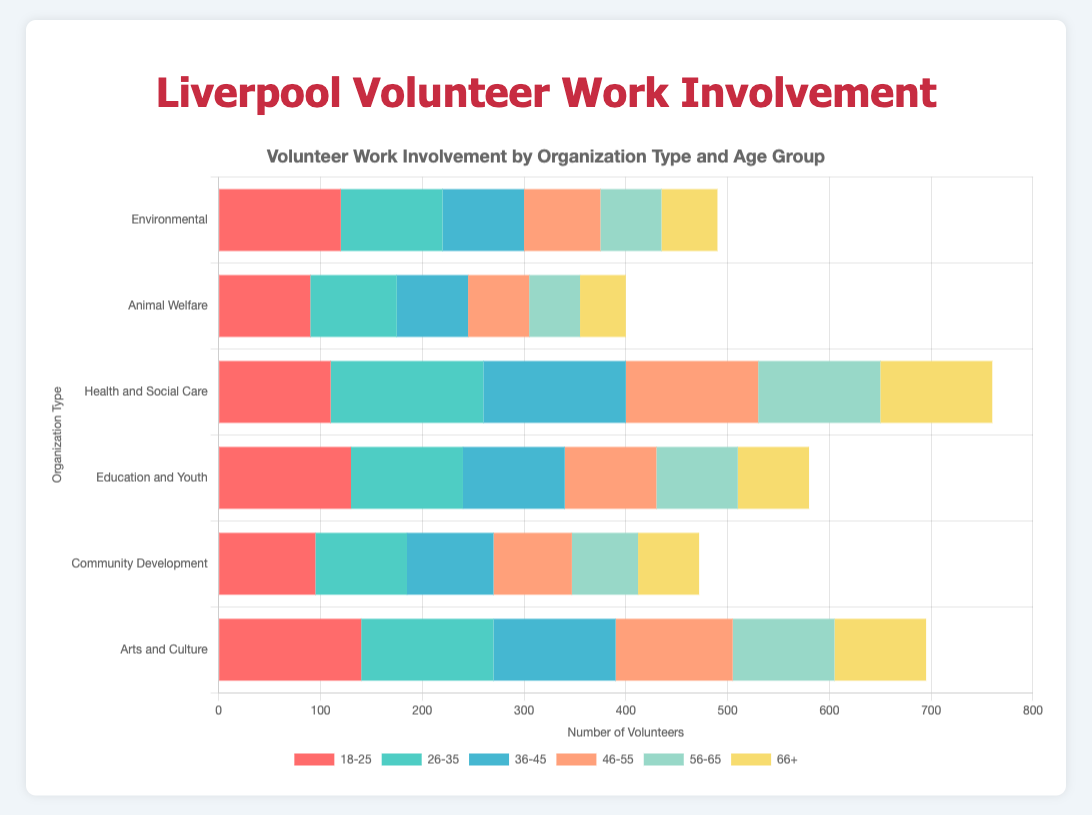Which organization type has the highest number of volunteers aged 18-25? Look at the horizontal bars representing the 18-25 age group and identify the longest one. The organization type "Arts and Culture" has the highest bar for this age group with 140 volunteers.
Answer: Arts and Culture Which organization type has the lowest number of volunteers aged 66+? Look for the shortest bar in the 66+ age group. The "Animal Welfare" category has the shortest bar, indicating 45 volunteers.
Answer: Animal Welfare What is the total number of volunteers in the "Health and Social Care" category? Sum the bars for all age groups in the "Health and Social Care" category: 110 (18-25) + 150 (26-35) + 140 (36-45) + 130 (46-55) + 120 (56-65) + 110 (66+).
Answer: 760 Compare the number of volunteers aged 26-35 in "Arts and Culture" to those in "Community Development." Which has more and by how much? The "Arts and Culture" category has 130 volunteers aged 26-35, and "Community Development" has 90. The difference is 130 - 90.
Answer: Arts and Culture, 40 more Which age group has the most volunteers across all organization types combined? Sum the number of volunteers for each age group across all organization types, then compare the totals. For example, for 18-25: 120 + 90 + 110 + 130 + 95 + 140, and so on for other age groups. The highest sum will give the answer.
Answer: 18-25 By how much does the number of volunteers in the 46-55 age group for "Education and Youth" exceed that for "Animal Welfare"? The "Education and Youth" category has 90 volunteers aged 46-55, while "Animal Welfare" has 60. The difference is 90 - 60.
Answer: 30 Identify the age group that has the smallest number of volunteers in "Environmental" organizations. Look at the bars for "Environmental" and identify the shortest one among the age groups. The 66+ age group has the smallest number, with 55 volunteers.
Answer: 66+ 